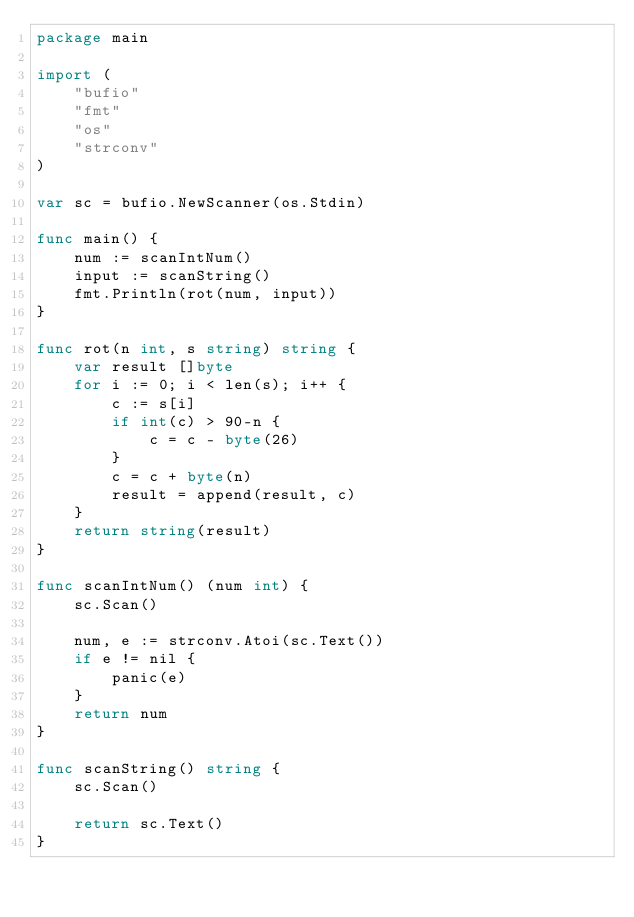Convert code to text. <code><loc_0><loc_0><loc_500><loc_500><_Go_>package main

import (
	"bufio"
	"fmt"
	"os"
	"strconv"
)

var sc = bufio.NewScanner(os.Stdin)

func main() {
	num := scanIntNum()
	input := scanString()
	fmt.Println(rot(num, input))
}

func rot(n int, s string) string {
	var result []byte
	for i := 0; i < len(s); i++ {
		c := s[i]
		if int(c) > 90-n {
			c = c - byte(26)
		}
		c = c + byte(n)
		result = append(result, c)
	}
	return string(result)
}

func scanIntNum() (num int) {
	sc.Scan()

	num, e := strconv.Atoi(sc.Text())
	if e != nil {
		panic(e)
	}
	return num
}

func scanString() string {
	sc.Scan()

	return sc.Text()
}</code> 